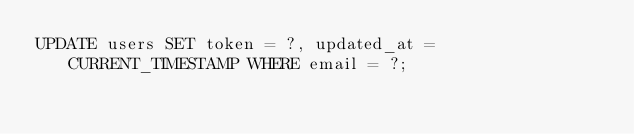<code> <loc_0><loc_0><loc_500><loc_500><_SQL_>UPDATE users SET token = ?, updated_at = CURRENT_TIMESTAMP WHERE email = ?;
</code> 